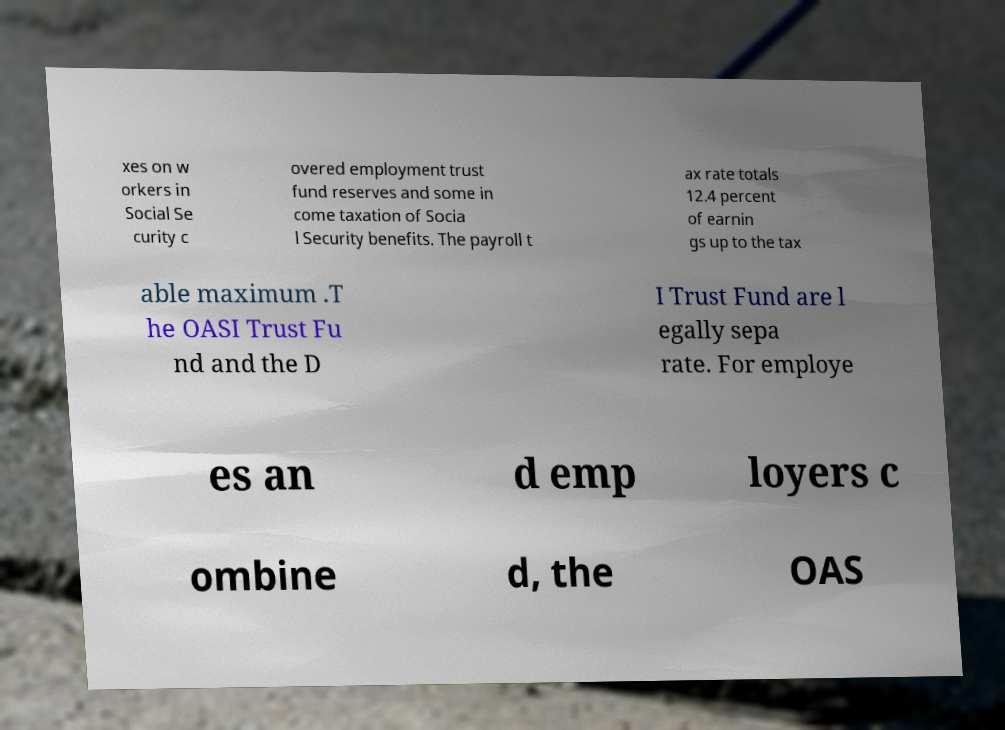Could you assist in decoding the text presented in this image and type it out clearly? xes on w orkers in Social Se curity c overed employment trust fund reserves and some in come taxation of Socia l Security benefits. The payroll t ax rate totals 12.4 percent of earnin gs up to the tax able maximum .T he OASI Trust Fu nd and the D I Trust Fund are l egally sepa rate. For employe es an d emp loyers c ombine d, the OAS 